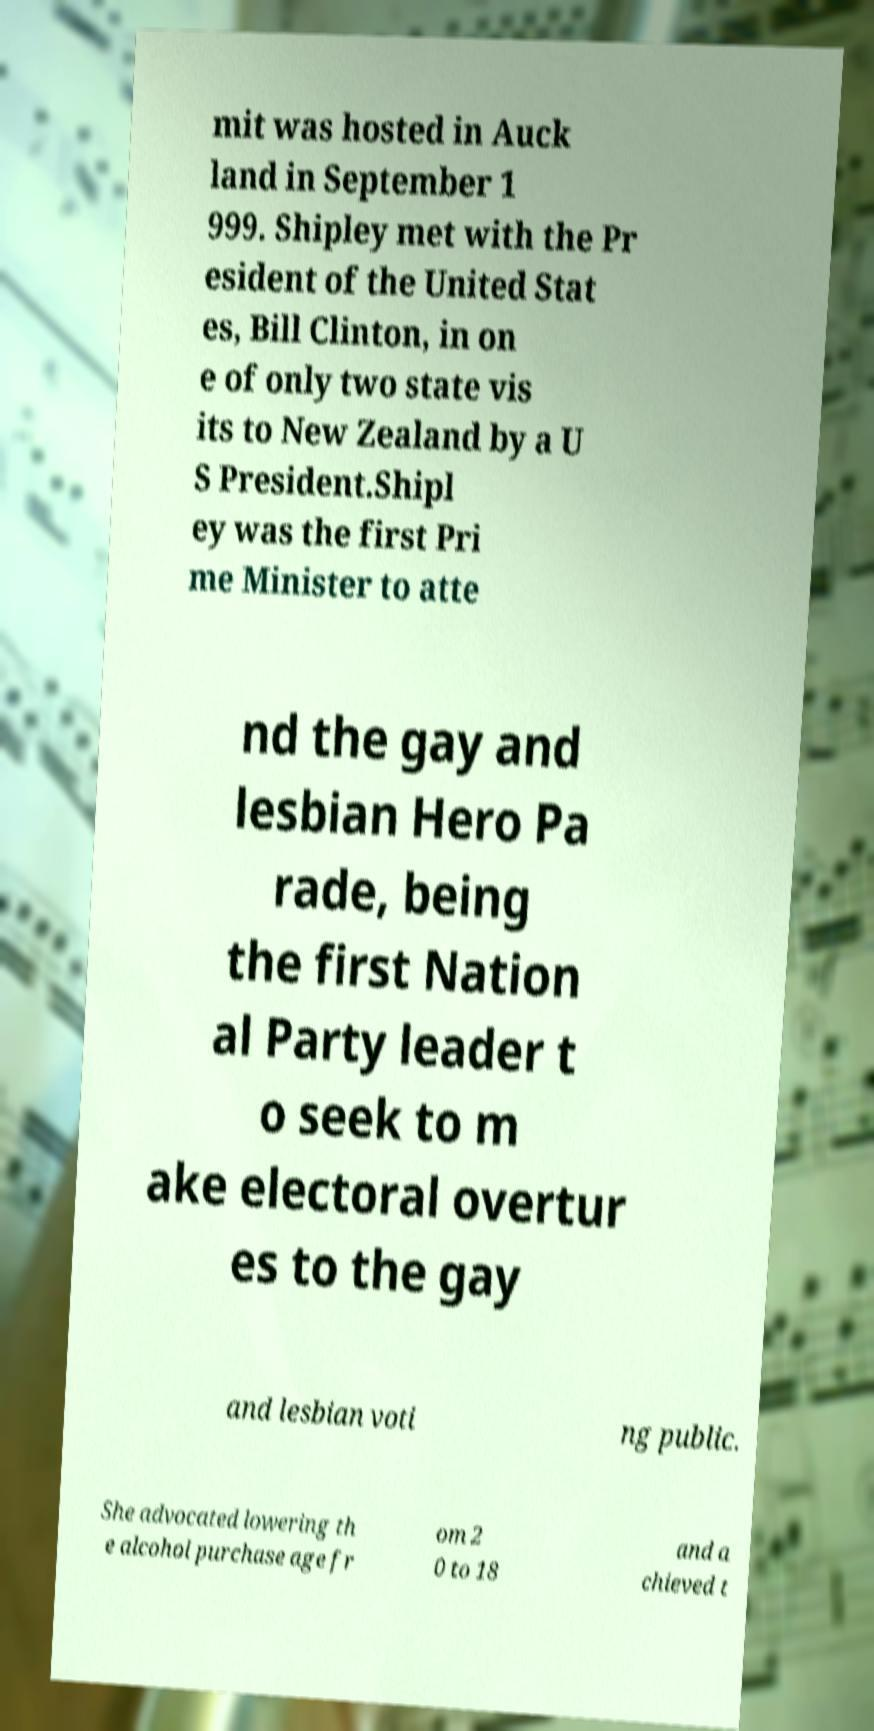Can you accurately transcribe the text from the provided image for me? mit was hosted in Auck land in September 1 999. Shipley met with the Pr esident of the United Stat es, Bill Clinton, in on e of only two state vis its to New Zealand by a U S President.Shipl ey was the first Pri me Minister to atte nd the gay and lesbian Hero Pa rade, being the first Nation al Party leader t o seek to m ake electoral overtur es to the gay and lesbian voti ng public. She advocated lowering th e alcohol purchase age fr om 2 0 to 18 and a chieved t 